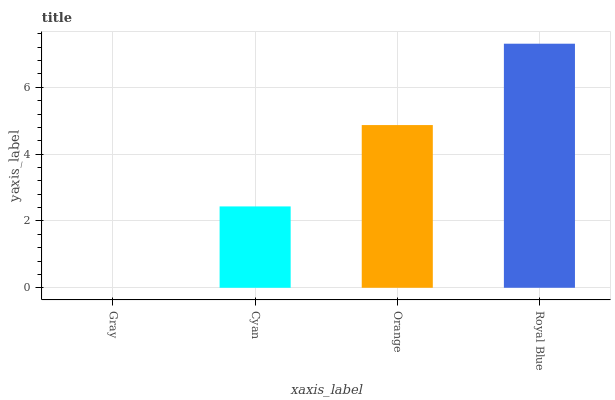Is Gray the minimum?
Answer yes or no. Yes. Is Royal Blue the maximum?
Answer yes or no. Yes. Is Cyan the minimum?
Answer yes or no. No. Is Cyan the maximum?
Answer yes or no. No. Is Cyan greater than Gray?
Answer yes or no. Yes. Is Gray less than Cyan?
Answer yes or no. Yes. Is Gray greater than Cyan?
Answer yes or no. No. Is Cyan less than Gray?
Answer yes or no. No. Is Orange the high median?
Answer yes or no. Yes. Is Cyan the low median?
Answer yes or no. Yes. Is Royal Blue the high median?
Answer yes or no. No. Is Gray the low median?
Answer yes or no. No. 